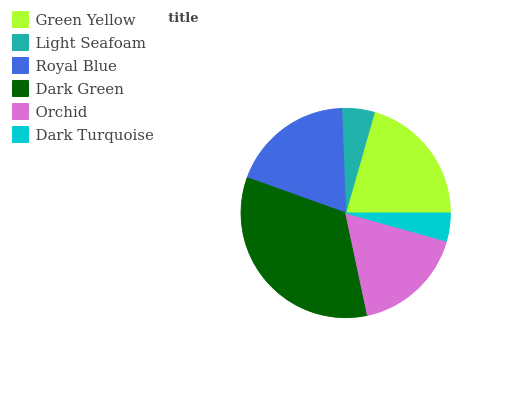Is Dark Turquoise the minimum?
Answer yes or no. Yes. Is Dark Green the maximum?
Answer yes or no. Yes. Is Light Seafoam the minimum?
Answer yes or no. No. Is Light Seafoam the maximum?
Answer yes or no. No. Is Green Yellow greater than Light Seafoam?
Answer yes or no. Yes. Is Light Seafoam less than Green Yellow?
Answer yes or no. Yes. Is Light Seafoam greater than Green Yellow?
Answer yes or no. No. Is Green Yellow less than Light Seafoam?
Answer yes or no. No. Is Royal Blue the high median?
Answer yes or no. Yes. Is Orchid the low median?
Answer yes or no. Yes. Is Green Yellow the high median?
Answer yes or no. No. Is Light Seafoam the low median?
Answer yes or no. No. 